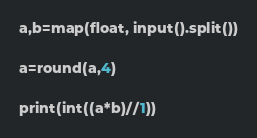Convert code to text. <code><loc_0><loc_0><loc_500><loc_500><_Python_>a,b=map(float, input().split())

a=round(a,4)

print(int((a*b)//1))</code> 